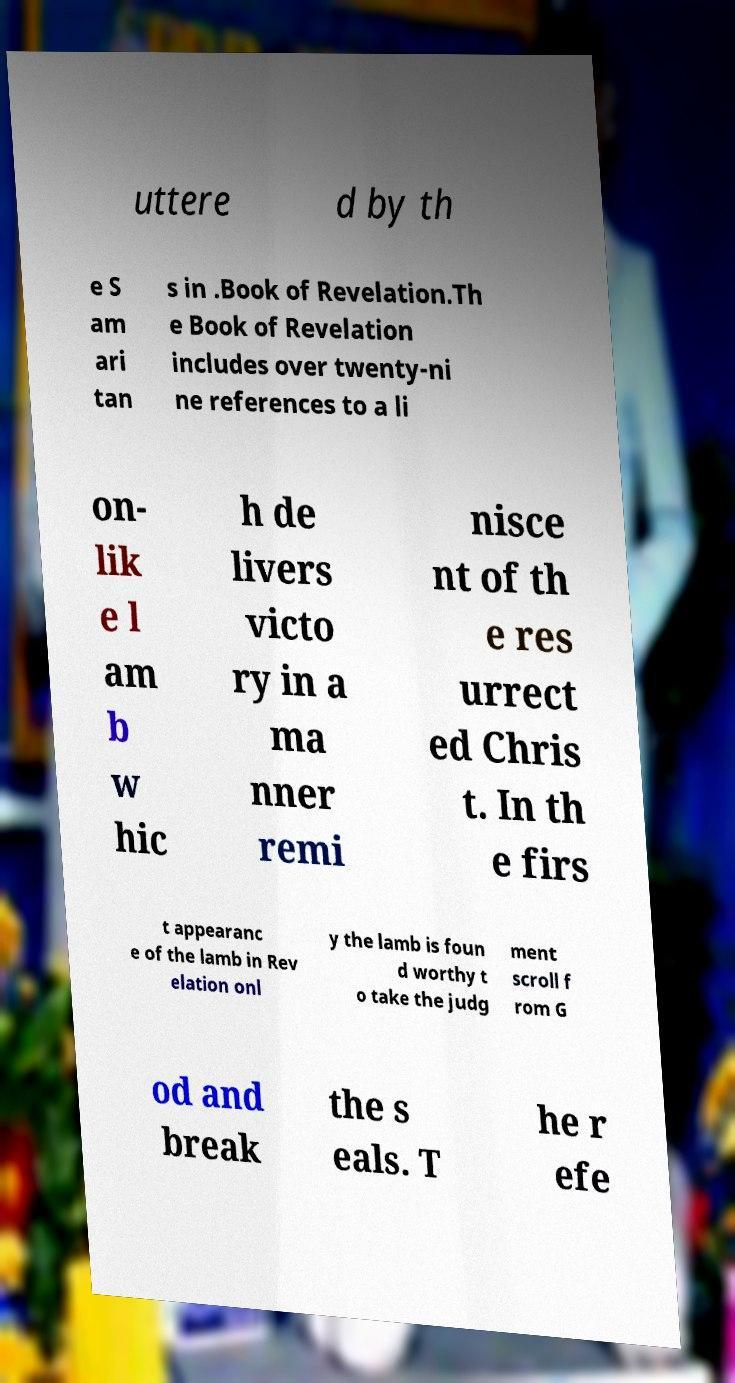Could you extract and type out the text from this image? uttere d by th e S am ari tan s in .Book of Revelation.Th e Book of Revelation includes over twenty-ni ne references to a li on- lik e l am b w hic h de livers victo ry in a ma nner remi nisce nt of th e res urrect ed Chris t. In th e firs t appearanc e of the lamb in Rev elation onl y the lamb is foun d worthy t o take the judg ment scroll f rom G od and break the s eals. T he r efe 